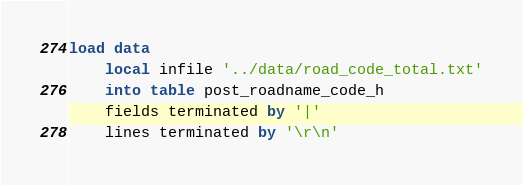Convert code to text. <code><loc_0><loc_0><loc_500><loc_500><_SQL_>load data 
	local infile '../data/road_code_total.txt'
	into table post_roadname_code_h
	fields terminated by '|'
	lines terminated by '\r\n'
</code> 